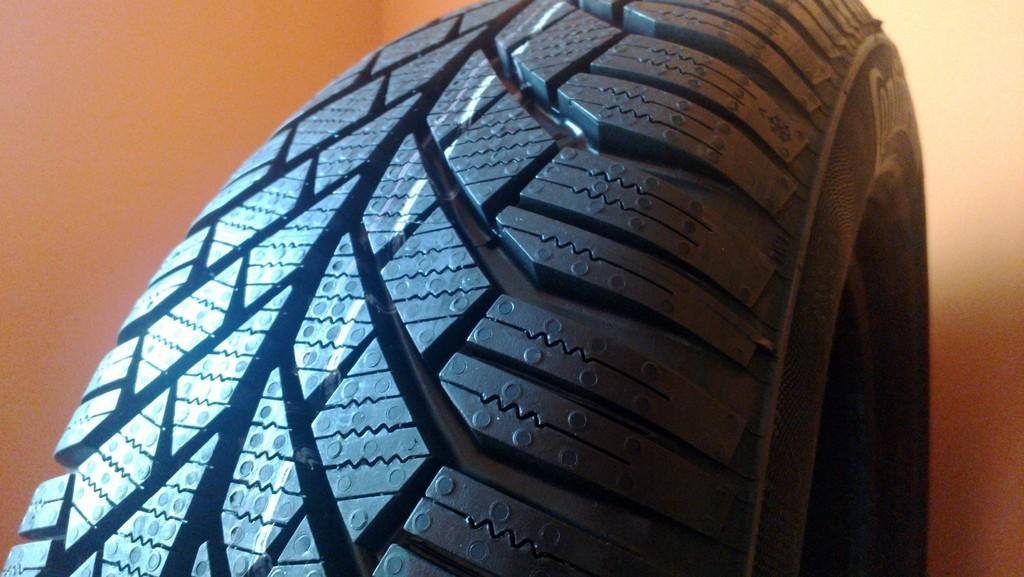Can you describe this image briefly? In this image we can see the wheel of a vehicle. 